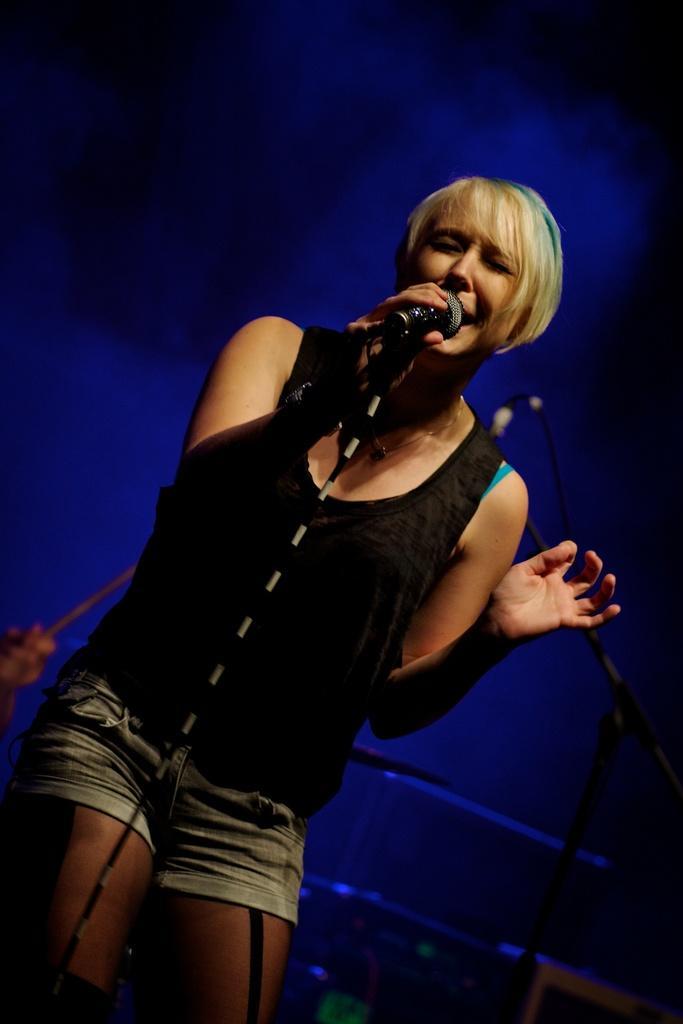In one or two sentences, can you explain what this image depicts? In the center of this picture we can see a woman wearing black color t-shirt, standing, holding a microphone and seems to be singing and in the background we can see the hand of a person holding some object and we can see the musical instruments and some other objects. 